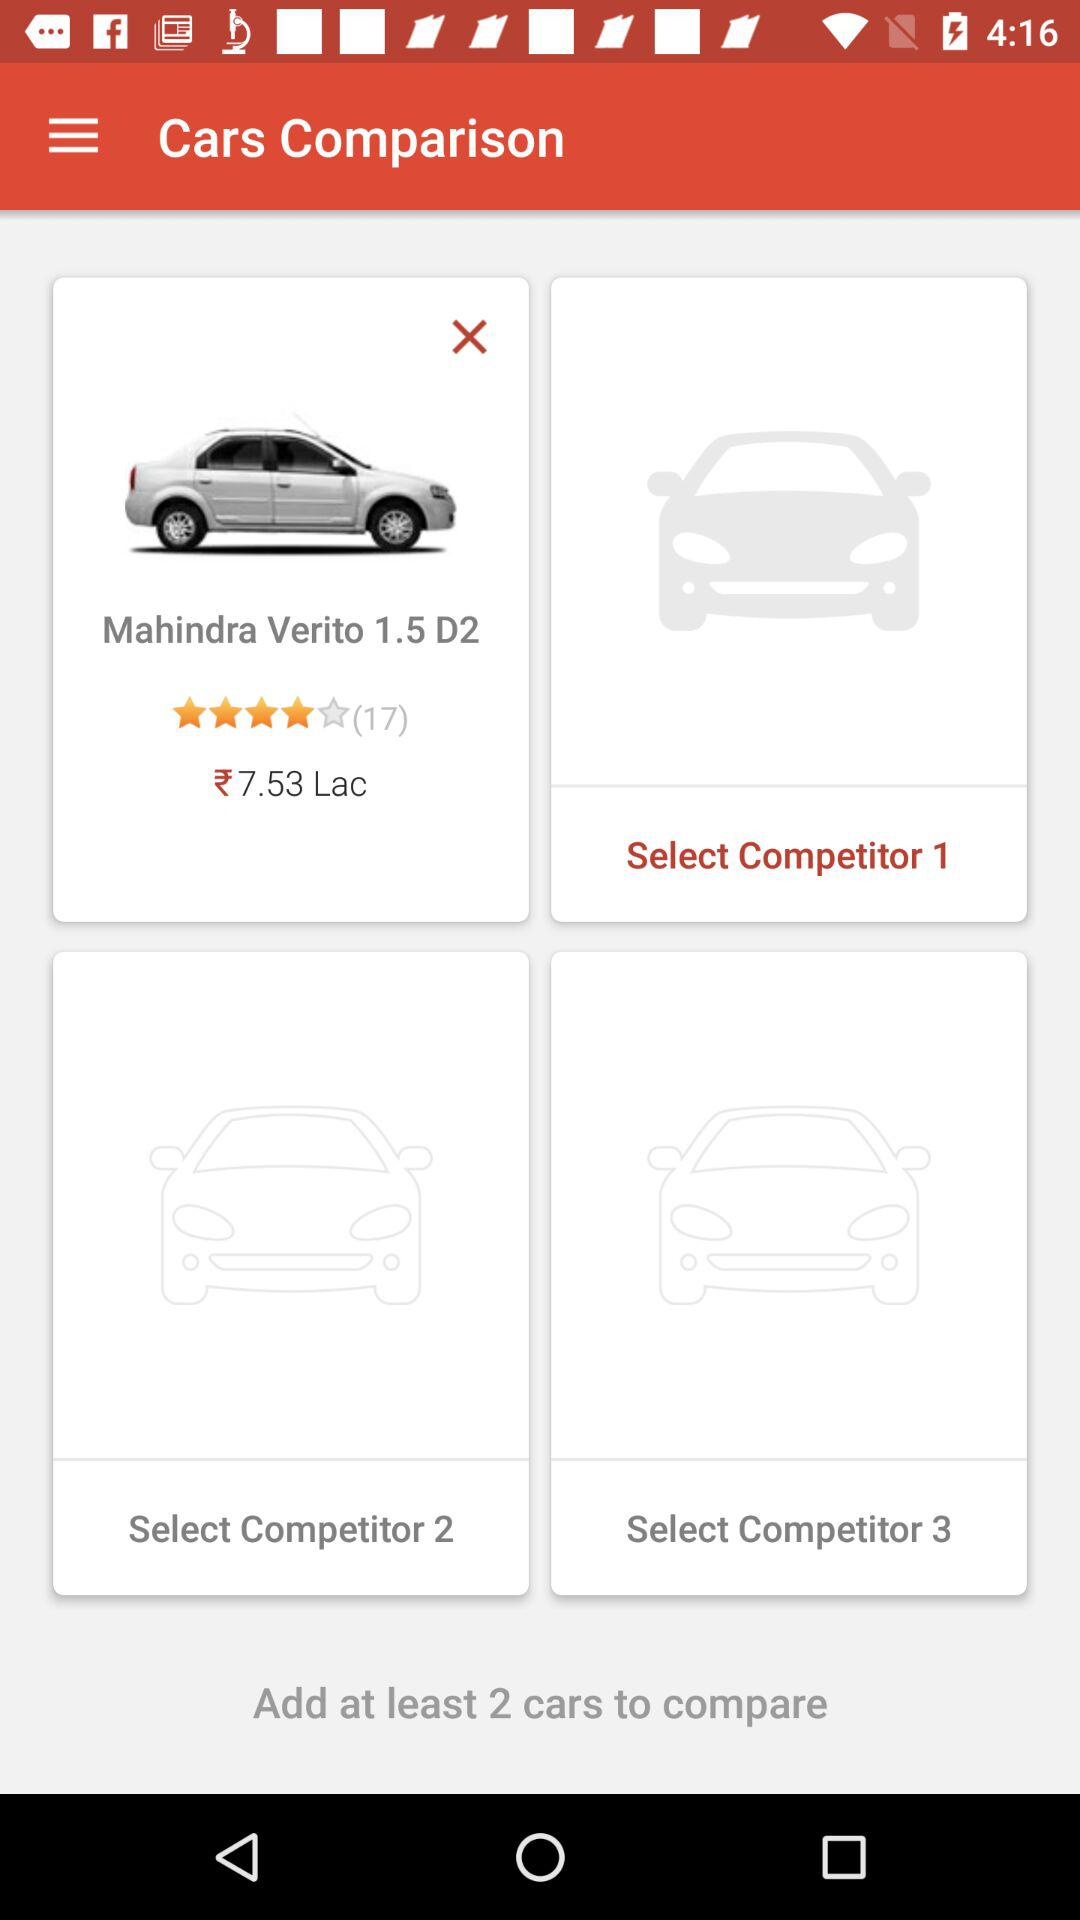What is the cost of the "Mahindra Verito 1.5 D2"? The cost is ₹7.53 Lac. 